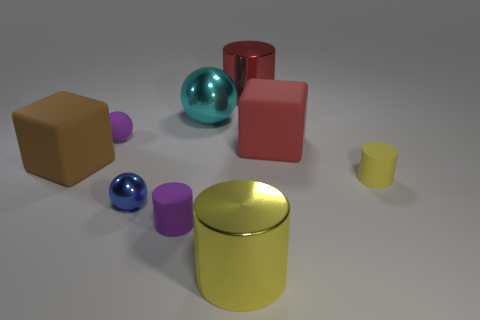Is the number of rubber balls greater than the number of big cyan cubes? In the image, there are two rubber balls and one large cyan cube. So yes, the number of rubber balls is indeed greater than the number of big cyan cubes. 